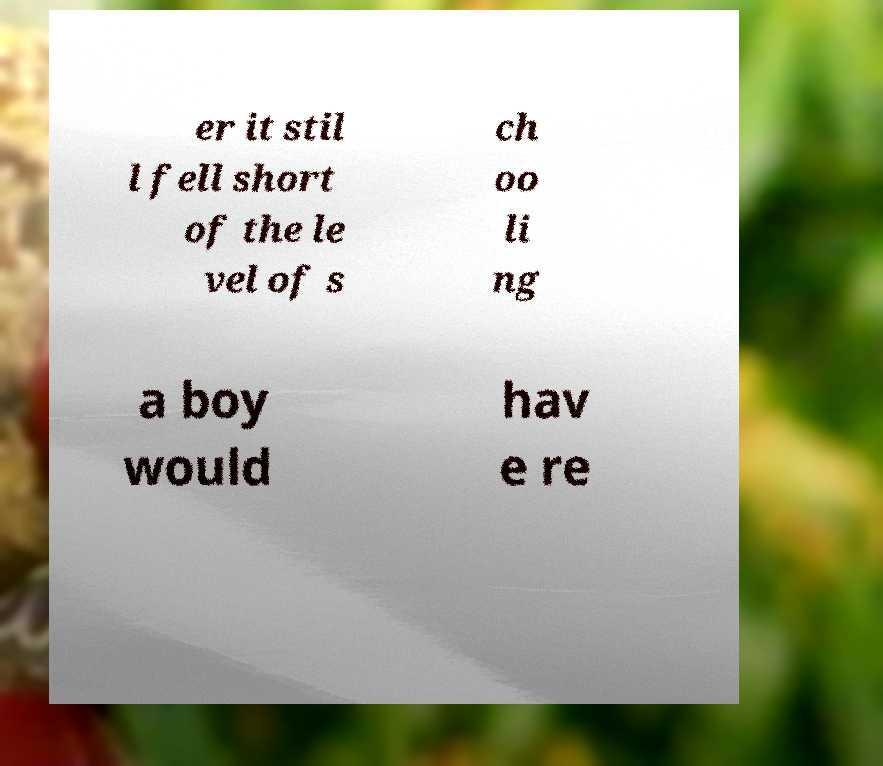Can you accurately transcribe the text from the provided image for me? er it stil l fell short of the le vel of s ch oo li ng a boy would hav e re 